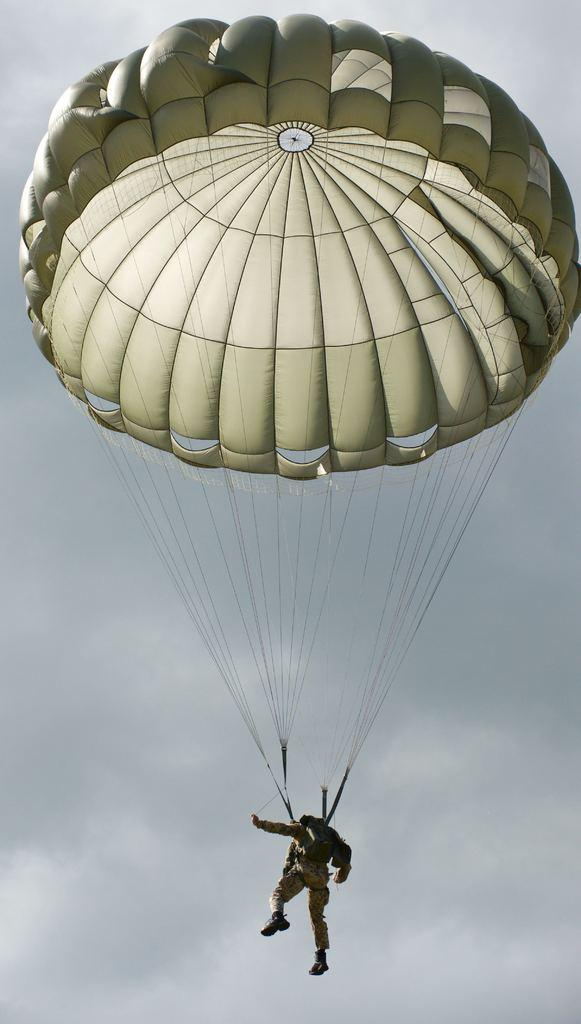What is happening to the person in the image? The person is flying in the air. How is the person flying in the air? The person is using a parachute. What type of note is the person holding while flying in the image? There is no note visible in the image; the person is using a parachute to fly. 